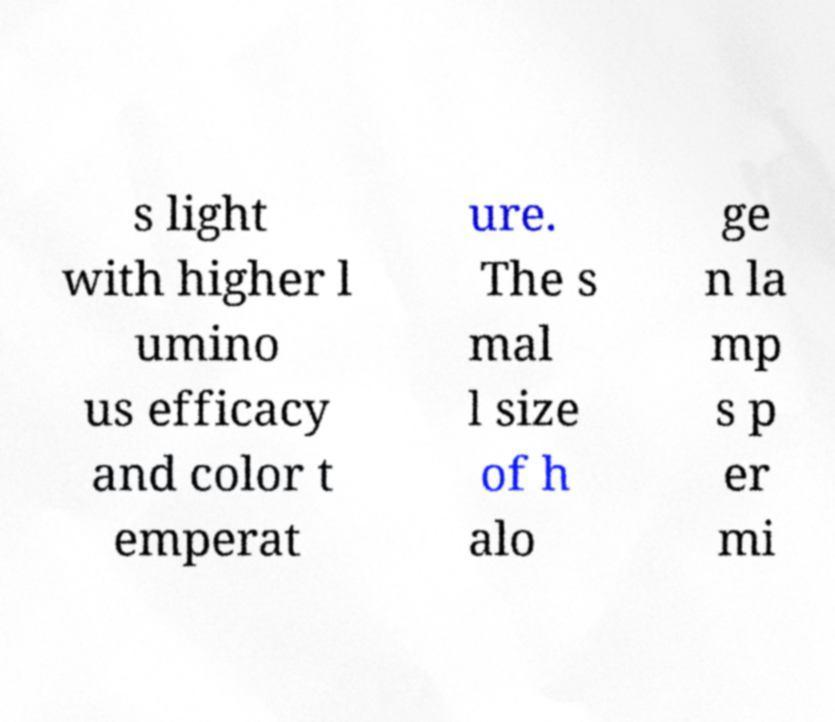Could you extract and type out the text from this image? s light with higher l umino us efficacy and color t emperat ure. The s mal l size of h alo ge n la mp s p er mi 